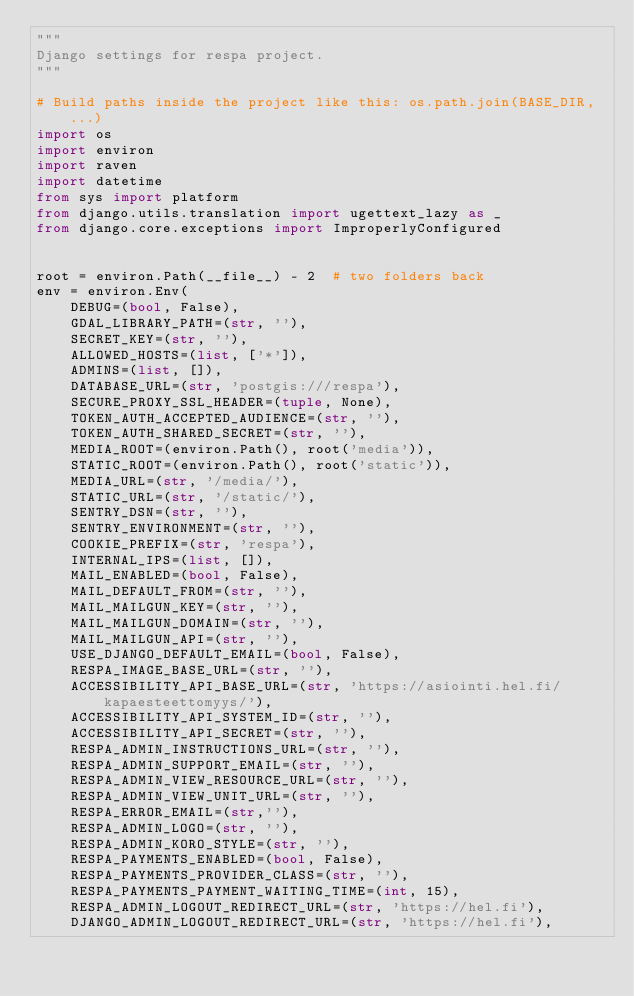<code> <loc_0><loc_0><loc_500><loc_500><_Python_>"""
Django settings for respa project.
"""

# Build paths inside the project like this: os.path.join(BASE_DIR, ...)
import os
import environ
import raven
import datetime
from sys import platform
from django.utils.translation import ugettext_lazy as _
from django.core.exceptions import ImproperlyConfigured


root = environ.Path(__file__) - 2  # two folders back
env = environ.Env(
    DEBUG=(bool, False),
    GDAL_LIBRARY_PATH=(str, ''),
    SECRET_KEY=(str, ''),
    ALLOWED_HOSTS=(list, ['*']),
    ADMINS=(list, []),
    DATABASE_URL=(str, 'postgis:///respa'),
    SECURE_PROXY_SSL_HEADER=(tuple, None),
    TOKEN_AUTH_ACCEPTED_AUDIENCE=(str, ''),
    TOKEN_AUTH_SHARED_SECRET=(str, ''),
    MEDIA_ROOT=(environ.Path(), root('media')),
    STATIC_ROOT=(environ.Path(), root('static')),
    MEDIA_URL=(str, '/media/'),
    STATIC_URL=(str, '/static/'),
    SENTRY_DSN=(str, ''),
    SENTRY_ENVIRONMENT=(str, ''),
    COOKIE_PREFIX=(str, 'respa'),
    INTERNAL_IPS=(list, []),
    MAIL_ENABLED=(bool, False),
    MAIL_DEFAULT_FROM=(str, ''),
    MAIL_MAILGUN_KEY=(str, ''),
    MAIL_MAILGUN_DOMAIN=(str, ''),
    MAIL_MAILGUN_API=(str, ''),
    USE_DJANGO_DEFAULT_EMAIL=(bool, False),
    RESPA_IMAGE_BASE_URL=(str, ''),
    ACCESSIBILITY_API_BASE_URL=(str, 'https://asiointi.hel.fi/kapaesteettomyys/'),
    ACCESSIBILITY_API_SYSTEM_ID=(str, ''),
    ACCESSIBILITY_API_SECRET=(str, ''),
    RESPA_ADMIN_INSTRUCTIONS_URL=(str, ''),
    RESPA_ADMIN_SUPPORT_EMAIL=(str, ''),
    RESPA_ADMIN_VIEW_RESOURCE_URL=(str, ''),
    RESPA_ADMIN_VIEW_UNIT_URL=(str, ''),
    RESPA_ERROR_EMAIL=(str,''),
    RESPA_ADMIN_LOGO=(str, ''),
    RESPA_ADMIN_KORO_STYLE=(str, ''),
    RESPA_PAYMENTS_ENABLED=(bool, False),
    RESPA_PAYMENTS_PROVIDER_CLASS=(str, ''),
    RESPA_PAYMENTS_PAYMENT_WAITING_TIME=(int, 15),
    RESPA_ADMIN_LOGOUT_REDIRECT_URL=(str, 'https://hel.fi'),
    DJANGO_ADMIN_LOGOUT_REDIRECT_URL=(str, 'https://hel.fi'),</code> 